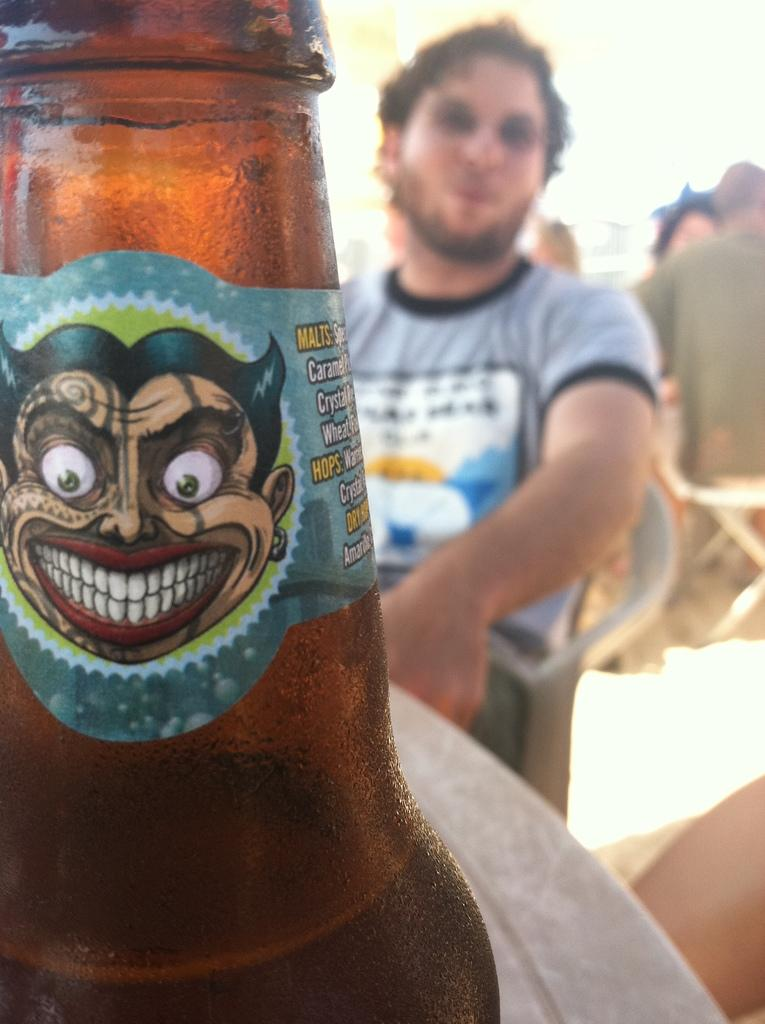Who is present in the image? There is a man in the image. What is the man doing in the image? The man is sitting on a chair in the image. What object can be seen in the image besides the man? There is a glass bottle in the image. How many kittens are playing with the curtain in the image? There are no kittens or curtains present in the image. What type of pizzas can be seen on the table in the image? There is no table or pizzas present in the image. 